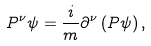Convert formula to latex. <formula><loc_0><loc_0><loc_500><loc_500>P ^ { \nu } \psi = \frac { i } { m } \partial ^ { \nu } \left ( P \psi \right ) ,</formula> 